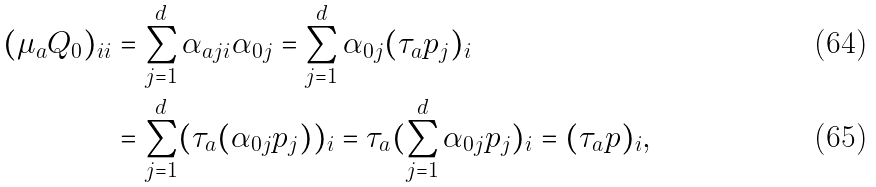<formula> <loc_0><loc_0><loc_500><loc_500>( \mu _ { a } Q _ { 0 } ) _ { i i } & = \sum _ { j = 1 } ^ { d } \alpha _ { a j i } \alpha _ { 0 j } = \sum _ { j = 1 } ^ { d } \alpha _ { 0 j } ( \tau _ { a } p _ { j } ) _ { i } \\ & = \sum _ { j = 1 } ^ { d } ( \tau _ { a } ( \alpha _ { 0 j } p _ { j } ) ) _ { i } = \tau _ { a } ( \sum _ { j = 1 } ^ { d } \alpha _ { 0 j } p _ { j } ) _ { i } = ( \tau _ { a } p ) _ { i } ,</formula> 